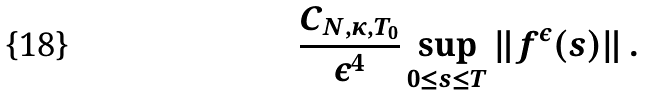Convert formula to latex. <formula><loc_0><loc_0><loc_500><loc_500>\frac { C _ { N , \kappa , T _ { 0 } } } { \varepsilon ^ { 4 } } \sup _ { 0 \leq s \leq T } \| f ^ { \varepsilon } ( s ) \| \, .</formula> 